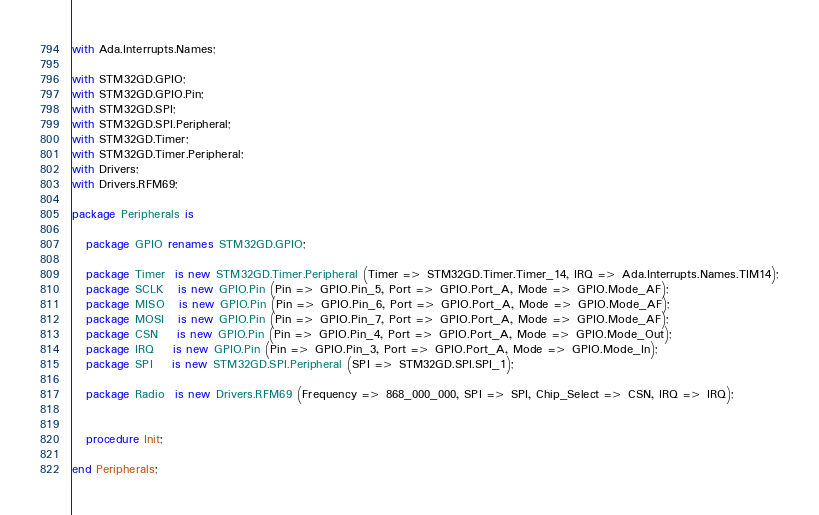<code> <loc_0><loc_0><loc_500><loc_500><_Ada_>with Ada.Interrupts.Names;

with STM32GD.GPIO;
with STM32GD.GPIO.Pin;
with STM32GD.SPI;
with STM32GD.SPI.Peripheral;
with STM32GD.Timer;
with STM32GD.Timer.Peripheral;
with Drivers;
with Drivers.RFM69;

package Peripherals is

   package GPIO renames STM32GD.GPIO;

   package Timer  is new STM32GD.Timer.Peripheral (Timer => STM32GD.Timer.Timer_14, IRQ => Ada.Interrupts.Names.TIM14);
   package SCLK   is new GPIO.Pin (Pin => GPIO.Pin_5, Port => GPIO.Port_A, Mode => GPIO.Mode_AF);
   package MISO   is new GPIO.Pin (Pin => GPIO.Pin_6, Port => GPIO.Port_A, Mode => GPIO.Mode_AF);
   package MOSI   is new GPIO.Pin (Pin => GPIO.Pin_7, Port => GPIO.Port_A, Mode => GPIO.Mode_AF);
   package CSN    is new GPIO.Pin (Pin => GPIO.Pin_4, Port => GPIO.Port_A, Mode => GPIO.Mode_Out);
   package IRQ    is new GPIO.Pin (Pin => GPIO.Pin_3, Port => GPIO.Port_A, Mode => GPIO.Mode_In);
   package SPI    is new STM32GD.SPI.Peripheral (SPI => STM32GD.SPI.SPI_1);

   package Radio  is new Drivers.RFM69 (Frequency => 868_000_000, SPI => SPI, Chip_Select => CSN, IRQ => IRQ);


   procedure Init;

end Peripherals;
</code> 